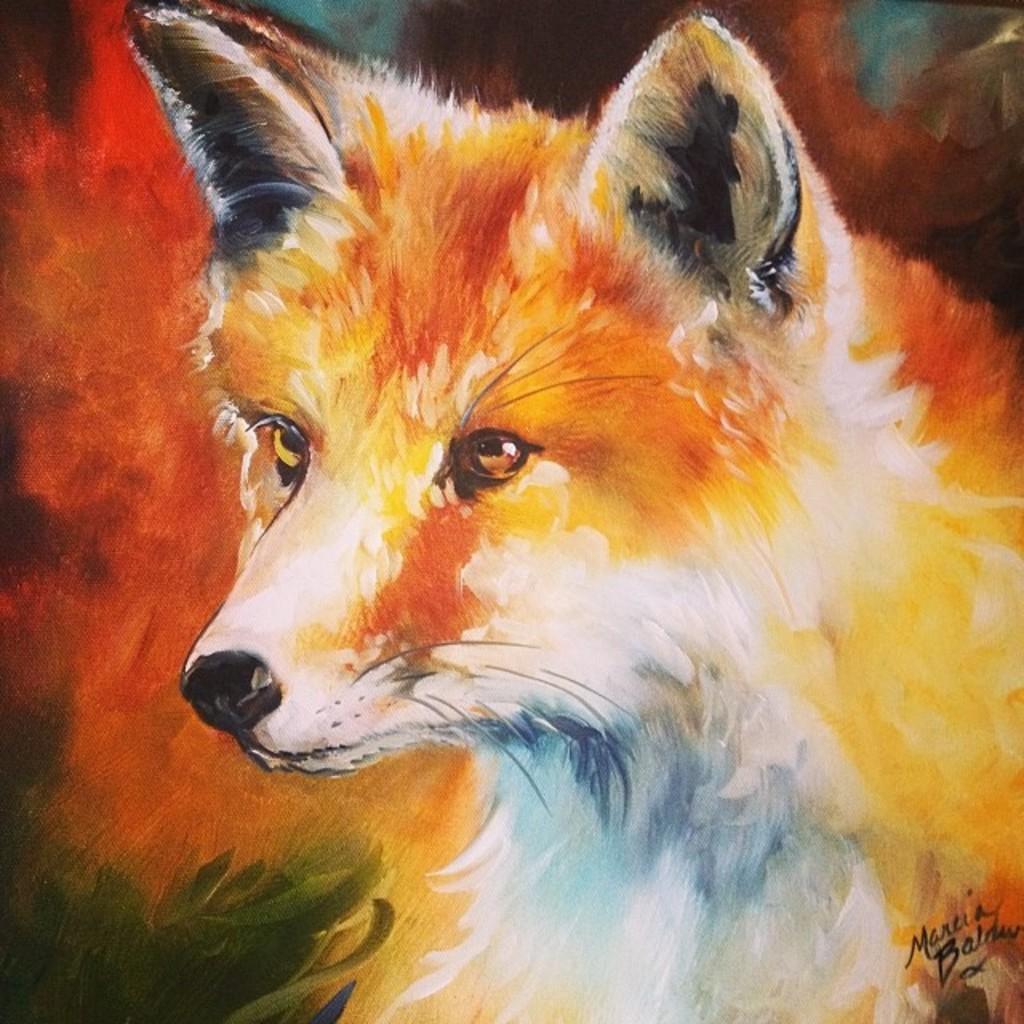Could you give a brief overview of what you see in this image? In this picture, we can see the painting on a dog and on the painting it is written something. 